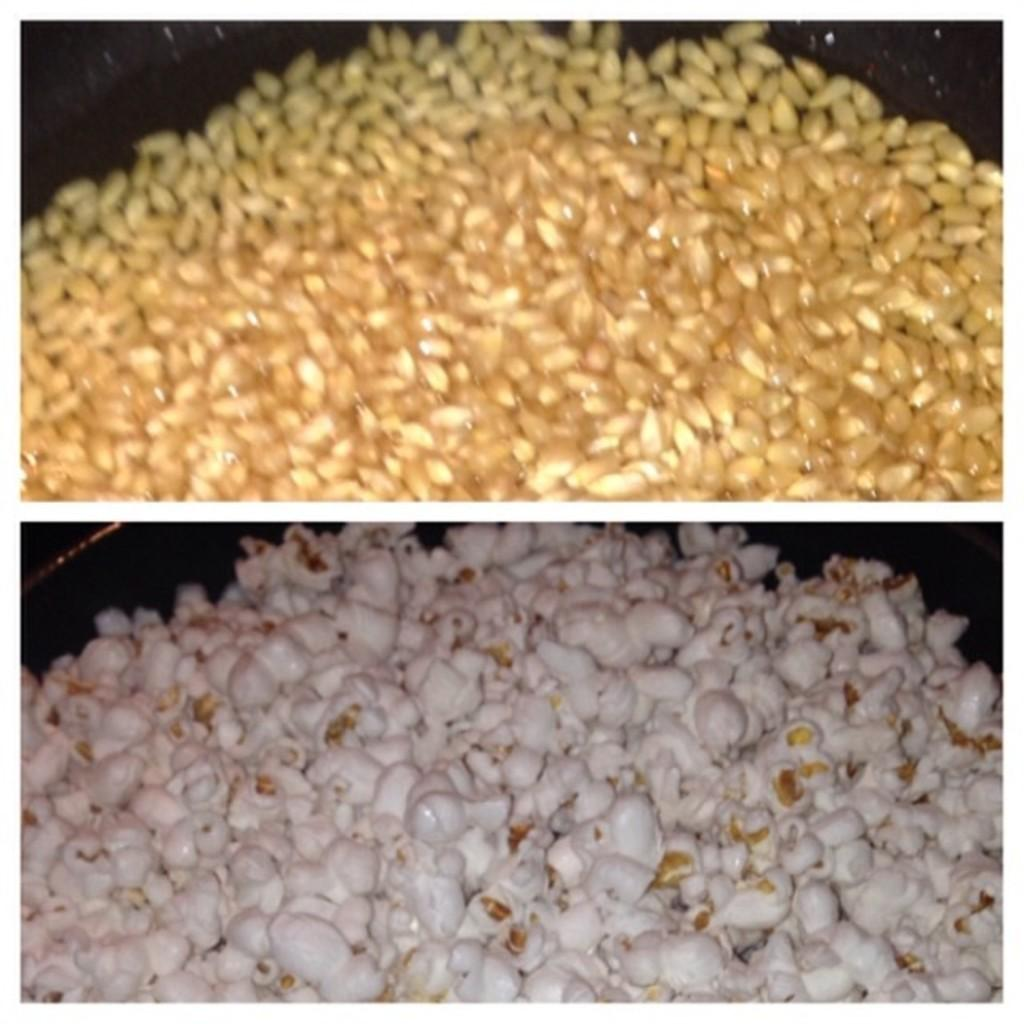What type of food is present at the bottom of the image? There is popcorn at the bottom of the image. What type of grain is present at the top of the image? There are wheat grains at the top of the image. Reasoning: Let'g: Let's think step by step in order to produce the conversation. We start by identifying the two main subjects in the image, which are the popcorn at the bottom and the wheat grains at the top. Then, we formulate questions that focus on the type of food and grain, ensuring that each question can be answered definitively with the information given. We avoid yes/no questions and ensure that the language is simple and clear. Absurd Question/Answer: What type of drug is hidden in the popcorn in the image? There is no drug present in the image; it only contains popcorn. Can you locate a map in the image? There is no map present in the image. What type of drug is hidden in the popcorn in the image? There is no drug present in the image; it only contains popcorn. Can you locate a map in the image? There is no map present in the image. 